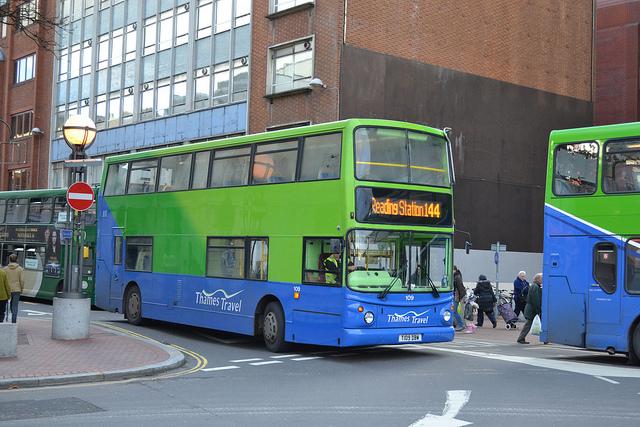Is the picture in black and white or color?
Keep it brief. Color. How many blue and green buses are there?
Short answer required. 2. What does the circle with the line inside me?
Concise answer only. Do not enter. What color is the sign by the bus?
Quick response, please. Red and white. 